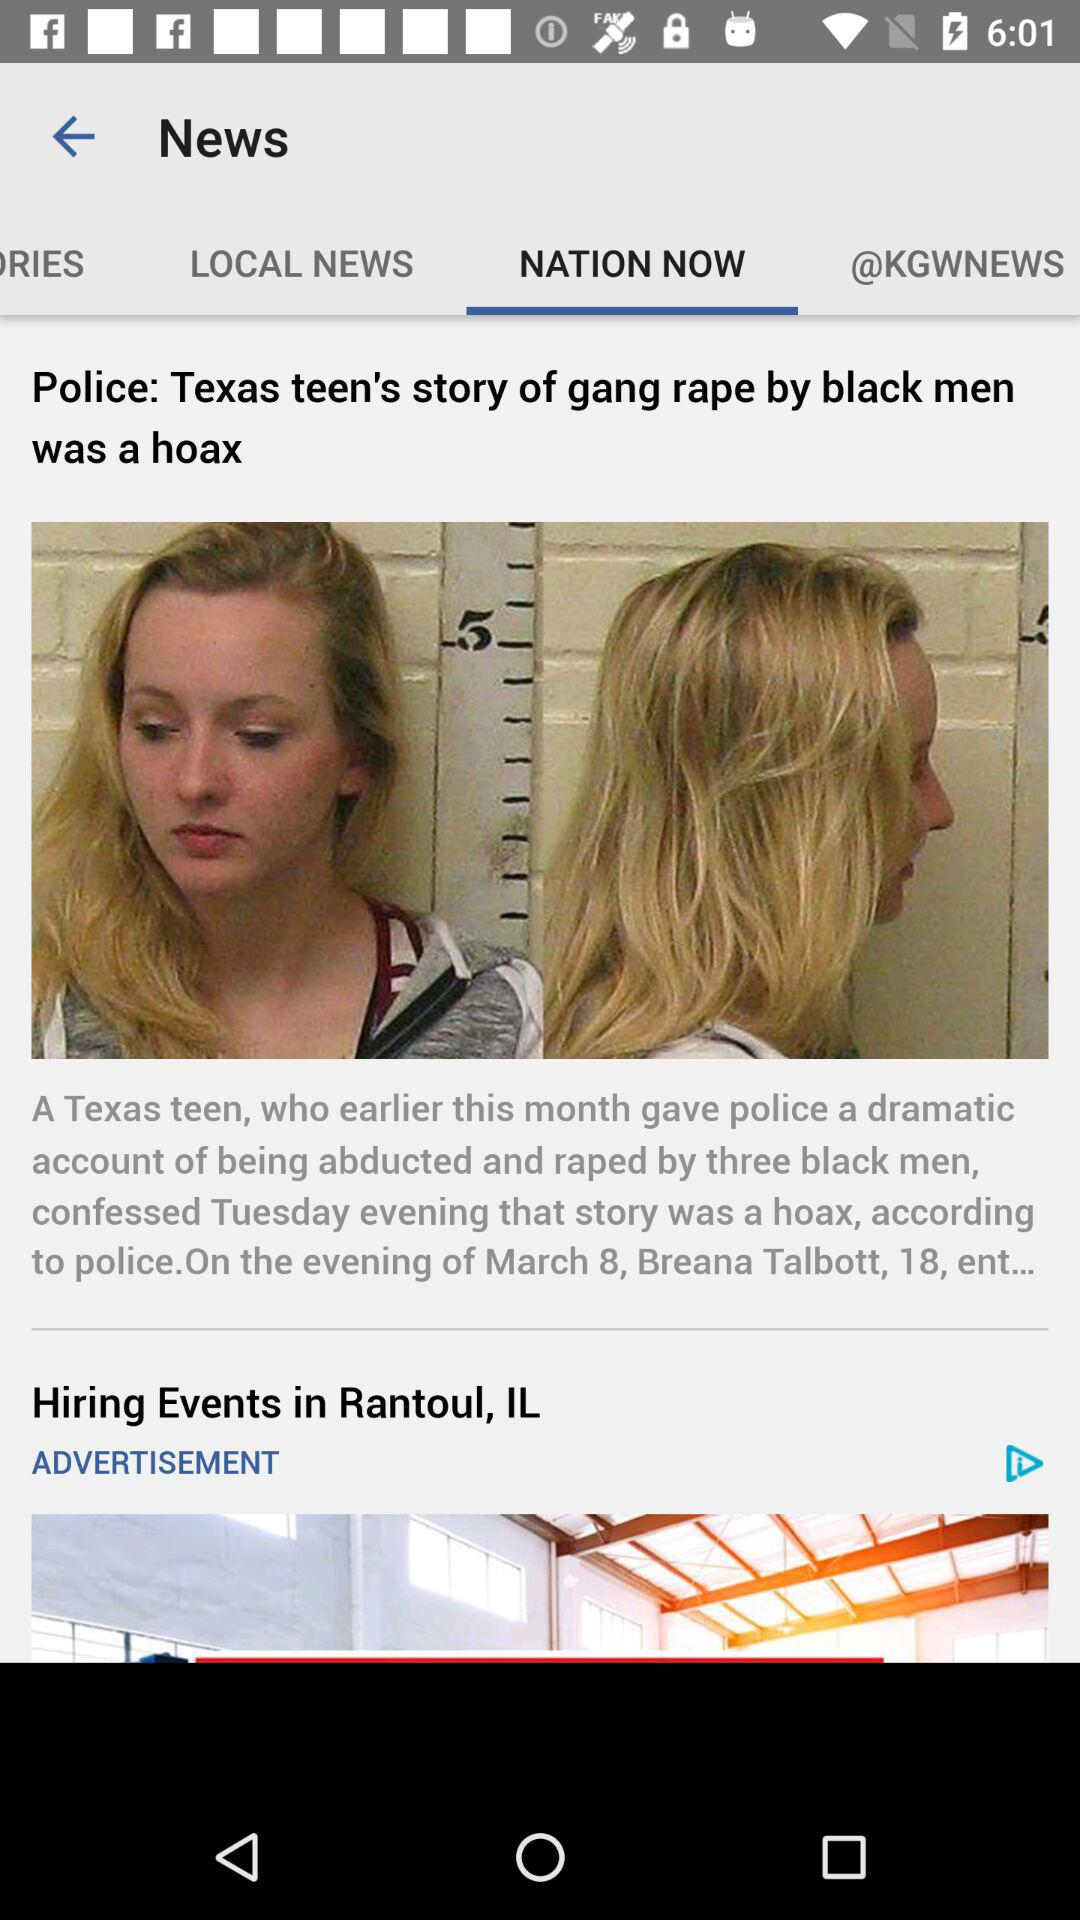Which tab is selected? The selected tab is "NATION NOW". 